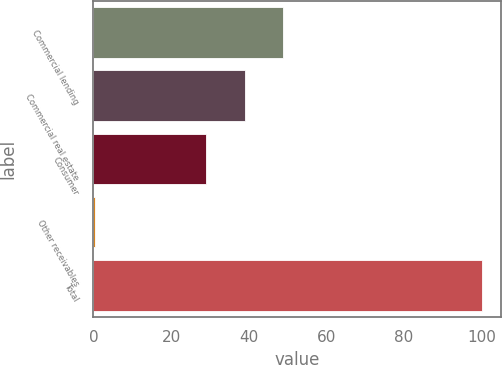<chart> <loc_0><loc_0><loc_500><loc_500><bar_chart><fcel>Commercial lending<fcel>Commercial real estate<fcel>Consumer<fcel>Other receivables<fcel>Total<nl><fcel>48.92<fcel>38.96<fcel>29<fcel>0.4<fcel>100<nl></chart> 